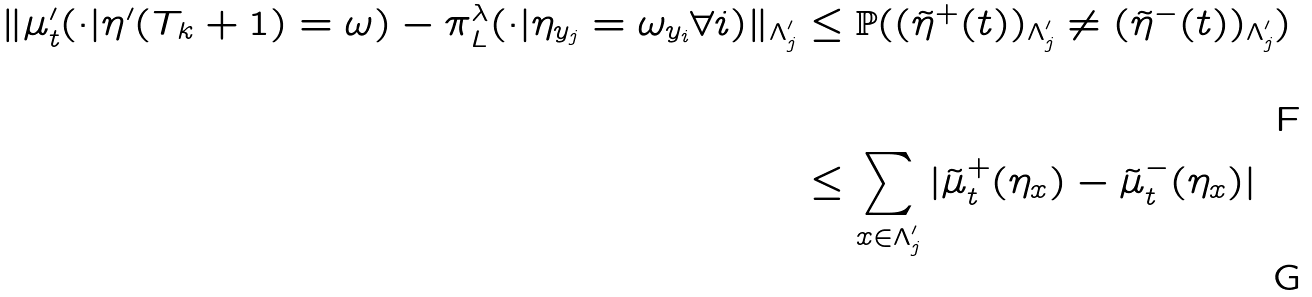<formula> <loc_0><loc_0><loc_500><loc_500>\| \mu ^ { \prime } _ { t } ( \cdot | \eta ^ { \prime } ( T _ { k } + 1 ) = \omega ) - \pi ^ { \lambda } _ { L } ( \cdot | \eta _ { y _ { j } } = \omega _ { y _ { i } } \forall i ) \| _ { \Lambda ^ { \prime } _ { j } } & \leq \mathbb { P } ( ( \tilde { \eta } ^ { + } ( t ) ) _ { \Lambda ^ { \prime } _ { j } } \ne ( \tilde { \eta } ^ { - } ( t ) ) _ { \Lambda ^ { \prime } _ { j } } ) \\ & \leq \sum _ { x \in \Lambda ^ { \prime } _ { j } } | \tilde { \mu } ^ { + } _ { t } ( \eta _ { x } ) - \tilde { \mu } ^ { - } _ { t } ( \eta _ { x } ) |</formula> 